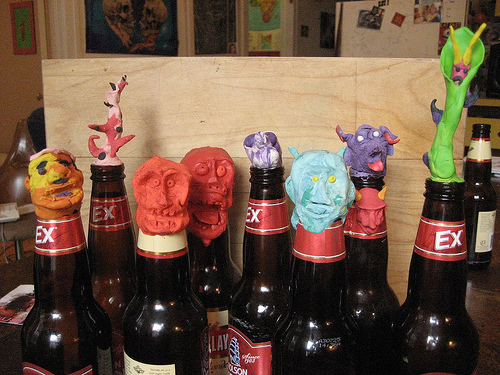<image>
Can you confirm if the sculpture is in the beer bottle? No. The sculpture is not contained within the beer bottle. These objects have a different spatial relationship. 